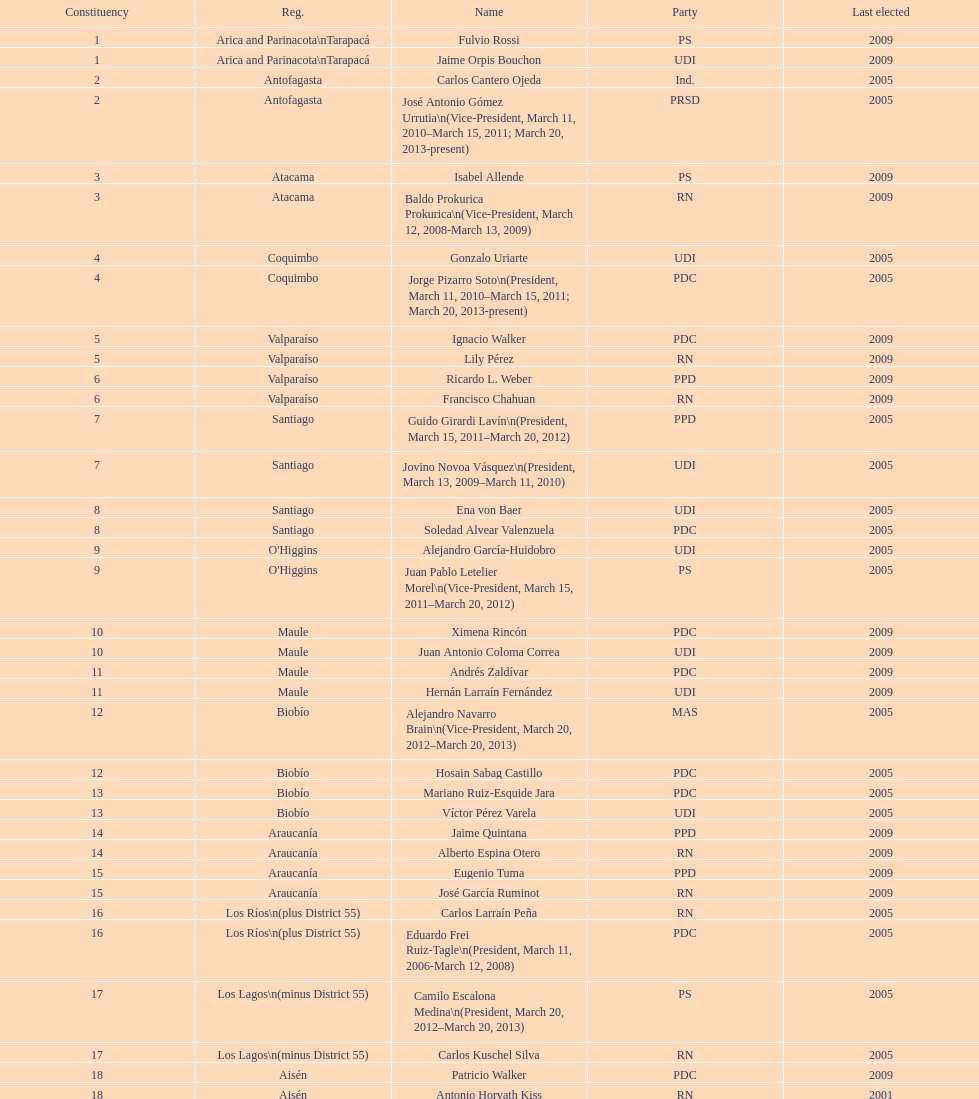Which party did jaime quintana belong to? PPD. 